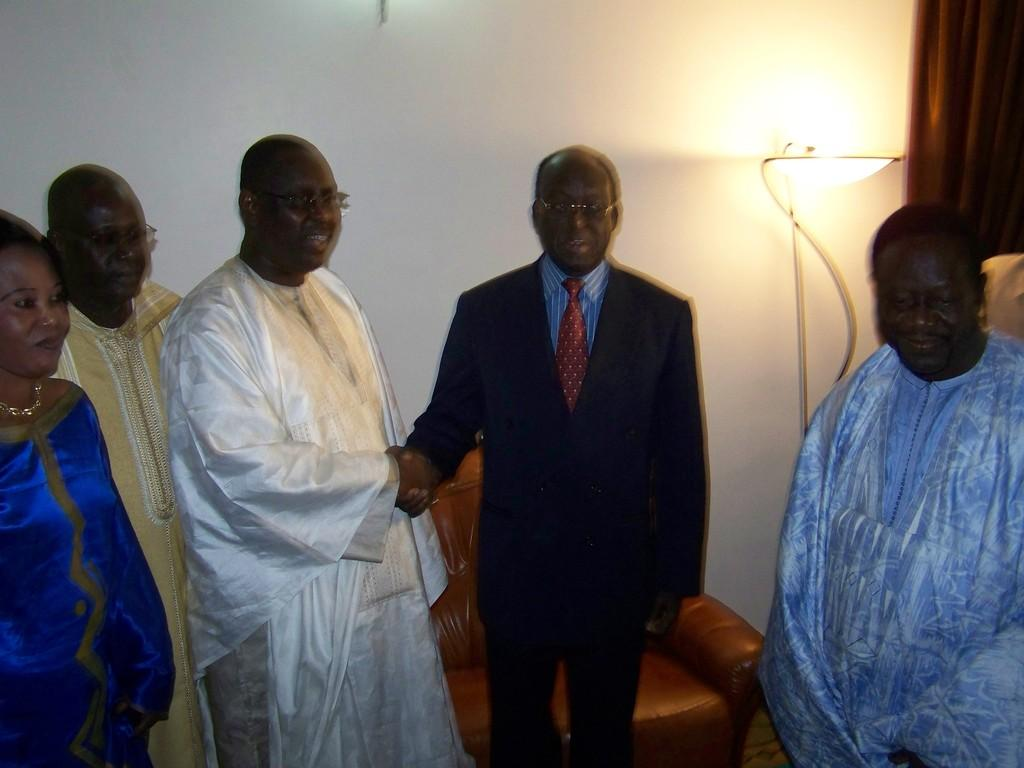How many people are in the image? There is a group of people in the image, but the exact number cannot be determined from the provided facts. What is the position of the people in the image? The people are standing on the floor in the image. What furniture is visible in the image? There is a chair and a lamp in the image. What type of window treatment is present in the image? There is a curtain in the image. What type of architectural feature is visible in the image? There is a wall in the image. What type of lunch is being served in the image? There is no mention of lunch or any food in the image. What game are the people playing in the image? There is no game or any indication of a game being played in the image. 